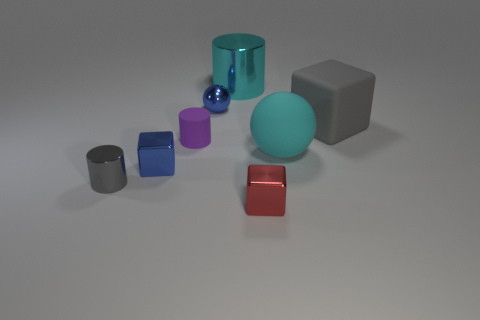Subtract all tiny cylinders. How many cylinders are left? 1 Subtract all purple cylinders. How many cylinders are left? 2 Subtract 2 balls. How many balls are left? 0 Subtract all blocks. How many objects are left? 5 Subtract all brown cylinders. How many purple cubes are left? 0 Add 1 gray objects. How many objects exist? 9 Subtract all purple cylinders. Subtract all yellow blocks. How many cylinders are left? 2 Subtract all blue metal cubes. Subtract all balls. How many objects are left? 5 Add 5 blue blocks. How many blue blocks are left? 6 Add 6 shiny spheres. How many shiny spheres exist? 7 